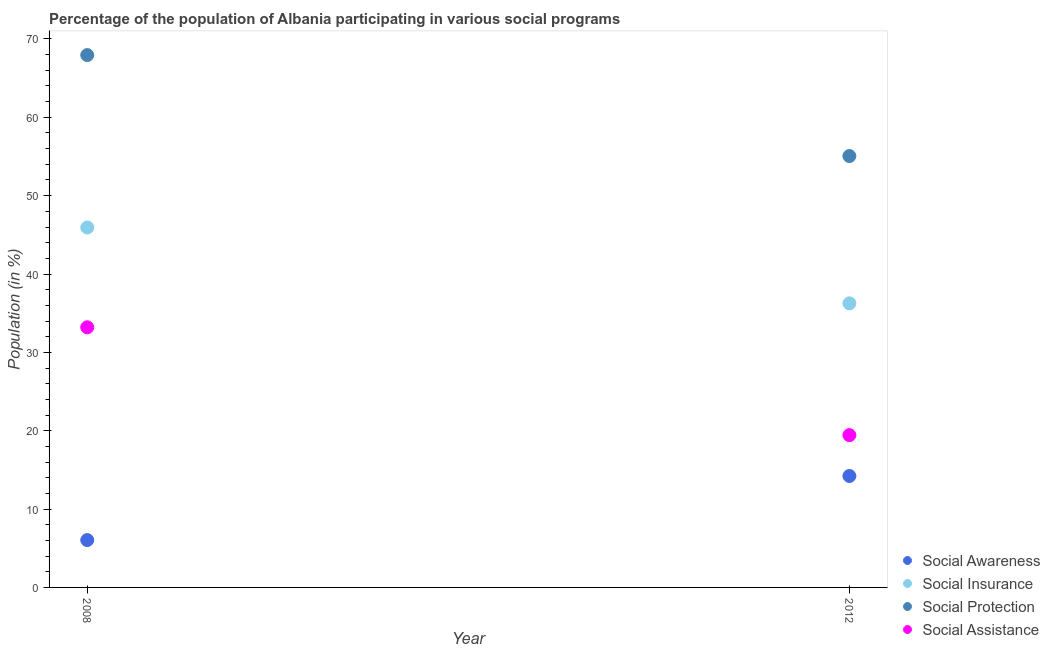How many different coloured dotlines are there?
Make the answer very short. 4. What is the participation of population in social protection programs in 2008?
Your response must be concise. 67.94. Across all years, what is the maximum participation of population in social protection programs?
Give a very brief answer. 67.94. Across all years, what is the minimum participation of population in social protection programs?
Offer a very short reply. 55.06. In which year was the participation of population in social insurance programs maximum?
Ensure brevity in your answer.  2008. What is the total participation of population in social assistance programs in the graph?
Keep it short and to the point. 52.64. What is the difference between the participation of population in social insurance programs in 2008 and that in 2012?
Make the answer very short. 9.68. What is the difference between the participation of population in social assistance programs in 2012 and the participation of population in social insurance programs in 2008?
Ensure brevity in your answer.  -26.5. What is the average participation of population in social insurance programs per year?
Offer a very short reply. 41.1. In the year 2012, what is the difference between the participation of population in social protection programs and participation of population in social awareness programs?
Your answer should be very brief. 40.83. What is the ratio of the participation of population in social awareness programs in 2008 to that in 2012?
Provide a succinct answer. 0.42. Is the participation of population in social protection programs in 2008 less than that in 2012?
Make the answer very short. No. How many dotlines are there?
Provide a succinct answer. 4. How many years are there in the graph?
Ensure brevity in your answer.  2. What is the difference between two consecutive major ticks on the Y-axis?
Provide a short and direct response. 10. Are the values on the major ticks of Y-axis written in scientific E-notation?
Your response must be concise. No. Does the graph contain grids?
Offer a very short reply. No. Where does the legend appear in the graph?
Offer a very short reply. Bottom right. How are the legend labels stacked?
Your response must be concise. Vertical. What is the title of the graph?
Provide a succinct answer. Percentage of the population of Albania participating in various social programs . Does "Structural Policies" appear as one of the legend labels in the graph?
Offer a terse response. No. What is the Population (in %) of Social Awareness in 2008?
Keep it short and to the point. 6.04. What is the Population (in %) in Social Insurance in 2008?
Provide a short and direct response. 45.94. What is the Population (in %) in Social Protection in 2008?
Your response must be concise. 67.94. What is the Population (in %) in Social Assistance in 2008?
Provide a succinct answer. 33.2. What is the Population (in %) in Social Awareness in 2012?
Make the answer very short. 14.22. What is the Population (in %) of Social Insurance in 2012?
Your answer should be compact. 36.26. What is the Population (in %) of Social Protection in 2012?
Your answer should be very brief. 55.06. What is the Population (in %) of Social Assistance in 2012?
Your answer should be very brief. 19.44. Across all years, what is the maximum Population (in %) in Social Awareness?
Your answer should be very brief. 14.22. Across all years, what is the maximum Population (in %) of Social Insurance?
Keep it short and to the point. 45.94. Across all years, what is the maximum Population (in %) in Social Protection?
Provide a succinct answer. 67.94. Across all years, what is the maximum Population (in %) of Social Assistance?
Your answer should be very brief. 33.2. Across all years, what is the minimum Population (in %) of Social Awareness?
Make the answer very short. 6.04. Across all years, what is the minimum Population (in %) in Social Insurance?
Give a very brief answer. 36.26. Across all years, what is the minimum Population (in %) of Social Protection?
Make the answer very short. 55.06. Across all years, what is the minimum Population (in %) of Social Assistance?
Give a very brief answer. 19.44. What is the total Population (in %) in Social Awareness in the graph?
Your response must be concise. 20.26. What is the total Population (in %) of Social Insurance in the graph?
Offer a terse response. 82.19. What is the total Population (in %) in Social Protection in the graph?
Provide a short and direct response. 123. What is the total Population (in %) of Social Assistance in the graph?
Your answer should be very brief. 52.64. What is the difference between the Population (in %) of Social Awareness in 2008 and that in 2012?
Give a very brief answer. -8.18. What is the difference between the Population (in %) of Social Insurance in 2008 and that in 2012?
Offer a terse response. 9.68. What is the difference between the Population (in %) of Social Protection in 2008 and that in 2012?
Offer a terse response. 12.89. What is the difference between the Population (in %) of Social Assistance in 2008 and that in 2012?
Keep it short and to the point. 13.76. What is the difference between the Population (in %) in Social Awareness in 2008 and the Population (in %) in Social Insurance in 2012?
Offer a very short reply. -30.21. What is the difference between the Population (in %) of Social Awareness in 2008 and the Population (in %) of Social Protection in 2012?
Keep it short and to the point. -49.01. What is the difference between the Population (in %) of Social Awareness in 2008 and the Population (in %) of Social Assistance in 2012?
Offer a terse response. -13.4. What is the difference between the Population (in %) in Social Insurance in 2008 and the Population (in %) in Social Protection in 2012?
Offer a terse response. -9.12. What is the difference between the Population (in %) of Social Insurance in 2008 and the Population (in %) of Social Assistance in 2012?
Offer a very short reply. 26.5. What is the difference between the Population (in %) in Social Protection in 2008 and the Population (in %) in Social Assistance in 2012?
Keep it short and to the point. 48.5. What is the average Population (in %) of Social Awareness per year?
Offer a terse response. 10.13. What is the average Population (in %) in Social Insurance per year?
Offer a terse response. 41.1. What is the average Population (in %) in Social Protection per year?
Offer a terse response. 61.5. What is the average Population (in %) of Social Assistance per year?
Your answer should be compact. 26.32. In the year 2008, what is the difference between the Population (in %) in Social Awareness and Population (in %) in Social Insurance?
Ensure brevity in your answer.  -39.9. In the year 2008, what is the difference between the Population (in %) in Social Awareness and Population (in %) in Social Protection?
Offer a very short reply. -61.9. In the year 2008, what is the difference between the Population (in %) of Social Awareness and Population (in %) of Social Assistance?
Your response must be concise. -27.16. In the year 2008, what is the difference between the Population (in %) of Social Insurance and Population (in %) of Social Protection?
Make the answer very short. -22. In the year 2008, what is the difference between the Population (in %) of Social Insurance and Population (in %) of Social Assistance?
Provide a succinct answer. 12.74. In the year 2008, what is the difference between the Population (in %) in Social Protection and Population (in %) in Social Assistance?
Your answer should be very brief. 34.74. In the year 2012, what is the difference between the Population (in %) in Social Awareness and Population (in %) in Social Insurance?
Give a very brief answer. -22.03. In the year 2012, what is the difference between the Population (in %) in Social Awareness and Population (in %) in Social Protection?
Keep it short and to the point. -40.83. In the year 2012, what is the difference between the Population (in %) of Social Awareness and Population (in %) of Social Assistance?
Ensure brevity in your answer.  -5.22. In the year 2012, what is the difference between the Population (in %) of Social Insurance and Population (in %) of Social Protection?
Your answer should be very brief. -18.8. In the year 2012, what is the difference between the Population (in %) in Social Insurance and Population (in %) in Social Assistance?
Keep it short and to the point. 16.81. In the year 2012, what is the difference between the Population (in %) in Social Protection and Population (in %) in Social Assistance?
Offer a very short reply. 35.62. What is the ratio of the Population (in %) in Social Awareness in 2008 to that in 2012?
Provide a succinct answer. 0.42. What is the ratio of the Population (in %) in Social Insurance in 2008 to that in 2012?
Make the answer very short. 1.27. What is the ratio of the Population (in %) of Social Protection in 2008 to that in 2012?
Provide a short and direct response. 1.23. What is the ratio of the Population (in %) of Social Assistance in 2008 to that in 2012?
Offer a very short reply. 1.71. What is the difference between the highest and the second highest Population (in %) in Social Awareness?
Provide a succinct answer. 8.18. What is the difference between the highest and the second highest Population (in %) of Social Insurance?
Offer a very short reply. 9.68. What is the difference between the highest and the second highest Population (in %) of Social Protection?
Keep it short and to the point. 12.89. What is the difference between the highest and the second highest Population (in %) of Social Assistance?
Your answer should be very brief. 13.76. What is the difference between the highest and the lowest Population (in %) of Social Awareness?
Give a very brief answer. 8.18. What is the difference between the highest and the lowest Population (in %) of Social Insurance?
Your response must be concise. 9.68. What is the difference between the highest and the lowest Population (in %) in Social Protection?
Offer a very short reply. 12.89. What is the difference between the highest and the lowest Population (in %) in Social Assistance?
Offer a very short reply. 13.76. 